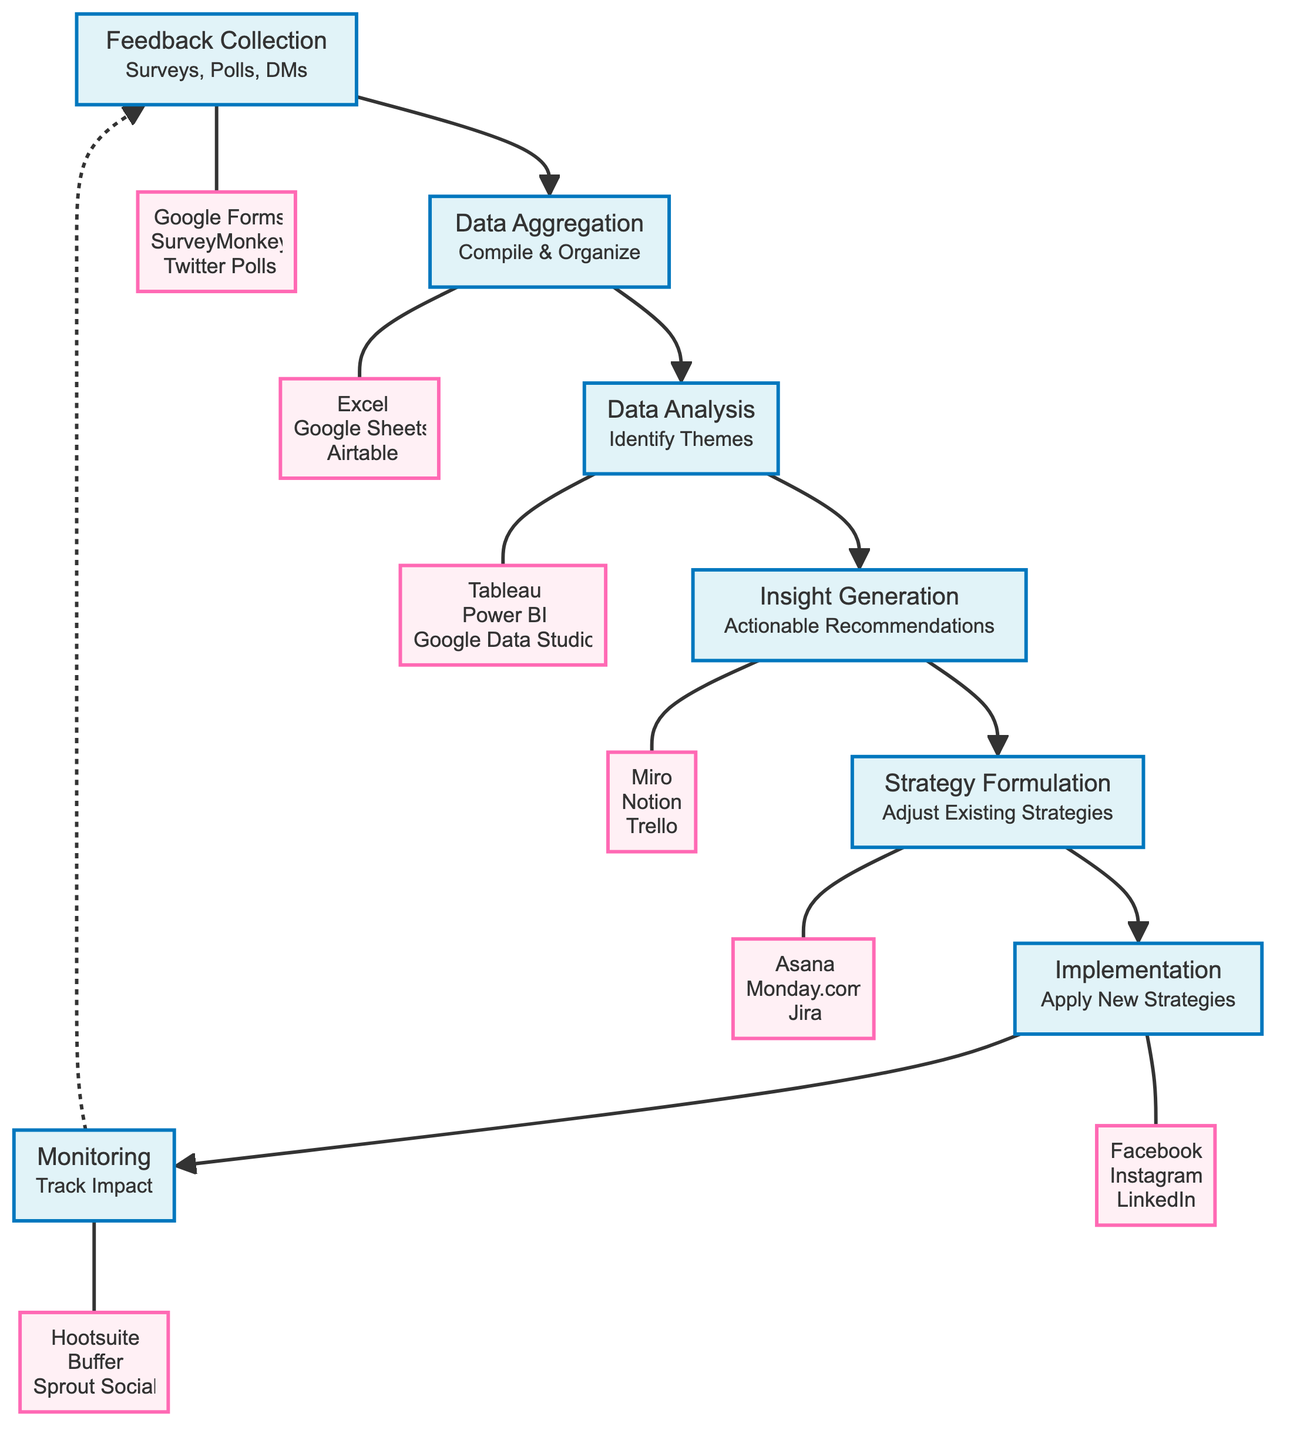What is the first step in the feedback loop process? The first step is "Feedback Collection," which involves gathering feedback from participants through various means.
Answer: Feedback Collection How many tools are suggested for data aggregation? Three tools are listed for data aggregation: Excel, Google Sheets, and Airtable.
Answer: Three Which node follows "Insight Generation" in the process? The node that follows "Insight Generation" is "Strategy Formulation." This indicates that insights are used to formulate strategies.
Answer: Strategy Formulation What is the last step of the feedback loop? The last step of the feedback loop process is "Monitoring," which tracks the impact of implemented strategies on participant engagement and satisfaction.
Answer: Monitoring Which tool is associated with the implementation of new strategies? The tools associated with implementation include Facebook, Instagram, and LinkedIn, which are platforms used to apply the new strategies.
Answer: Facebook, Instagram, LinkedIn What is the relationship between "Data Analysis" and "Insight Generation"? "Data Analysis" leads to "Insight Generation," meaning that insights are derived from the analyzed data.
Answer: Leads to How does the feedback loop process get initiated again? The feedback loop process gets initiated again through "Monitoring," which connects back to "Feedback Collection," indicating a continuous cycle of improvement.
Answer: Feedback Collection Which step encompasses compiling and organizing collected feedback data? The step that encompasses compiling and organizing collected feedback data is "Data Aggregation." This shows that data must be organized before analysis.
Answer: Data Aggregation What type of questions does "Insight Generation" aim to address? "Insight Generation" aims to generate actionable recommendations based on analyzed data, focusing on improvements for future workshops.
Answer: Actionable Recommendations 